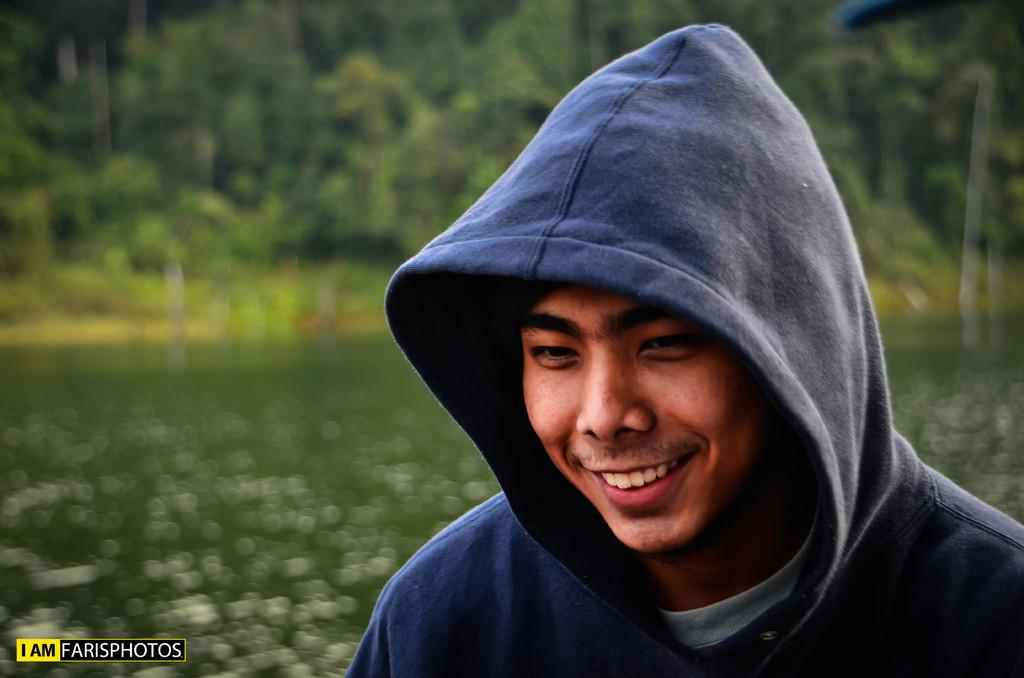Who is present in the image? There is a man in the image. What is the man wearing? The man is wearing a hoodie. What is the man's facial expression? The man is smiling. What can be seen in the background of the image? There are trees and water visible in the background of the image. What type of boot can be seen on the man's foot in the image? There is no boot visible on the man's foot in the image; he is wearing a hoodie, but no footwear is mentioned. 